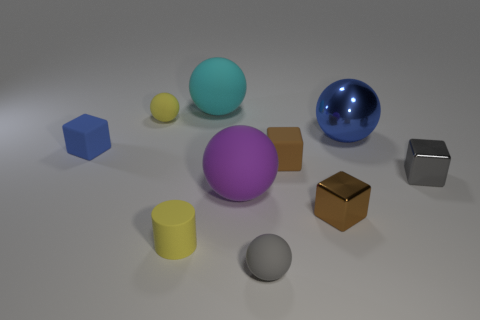Can you describe the lighting and atmosphere of the scene? The scene is softly lit with what seems to be natural, diffused daylight, creating gentle shadows and giving the image a serene, almost studio-like atmosphere. 